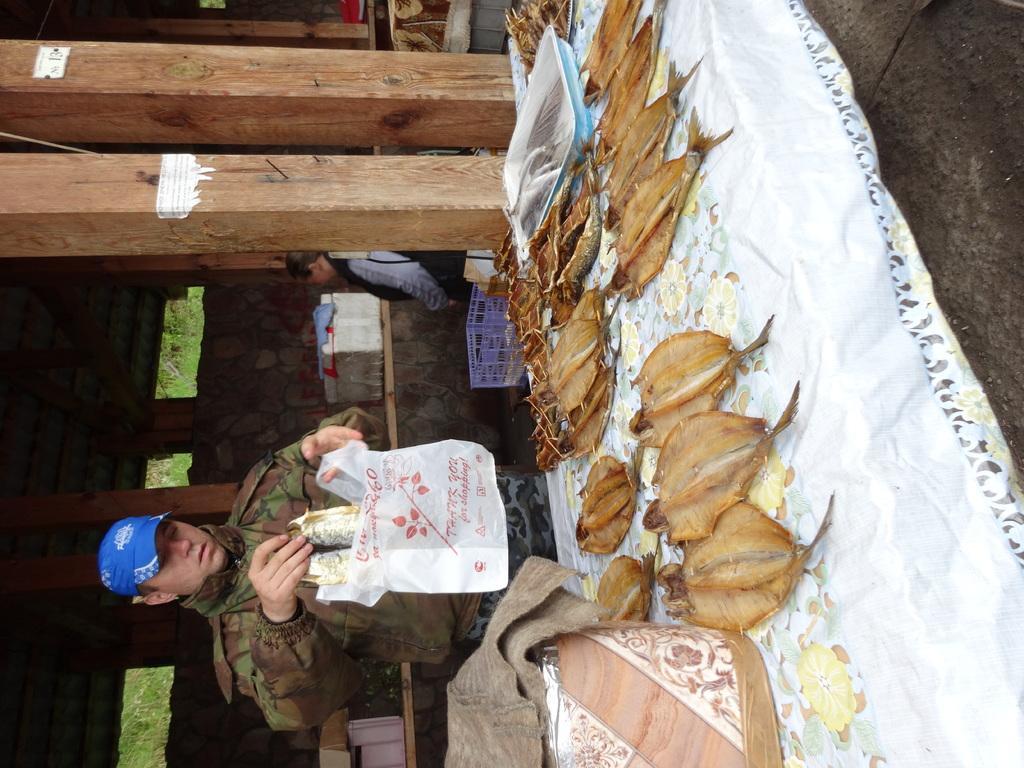Please provide a concise description of this image. In the picture there is a shop and a lot of fishes are kept for sale,the shopkeeper is putting two fishes into the cover,beside the shopkeeper there are two wooden pillars and behind the pillars there is a man standing in front of a white color box. 